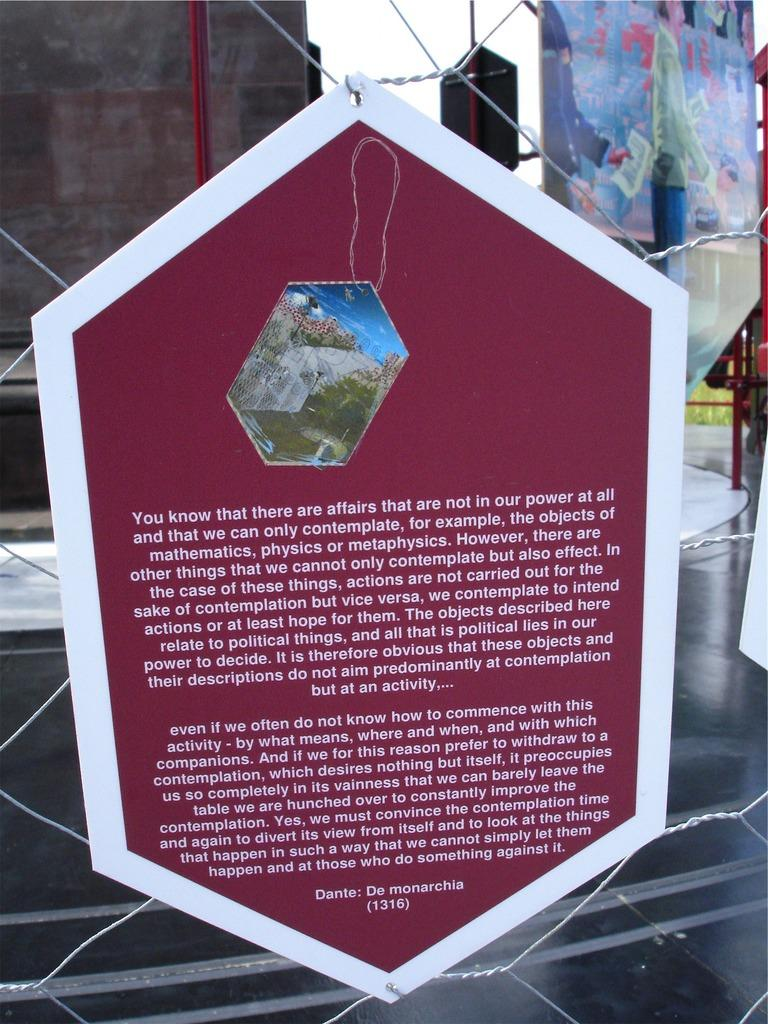What is the main structure visible in the image? There is a wire mesh in the image. What is attached to the wire mesh? There is a poster on the wire mesh. What can be read on the poster? Something is written on the poster. What can be seen in the background of the image? There is a road and a wall visible in the background of the image. What type of hospital can be seen in the image? There is no hospital present in the image. What mode of transport is visible in the image? There is no mode of transport visible in the image. 